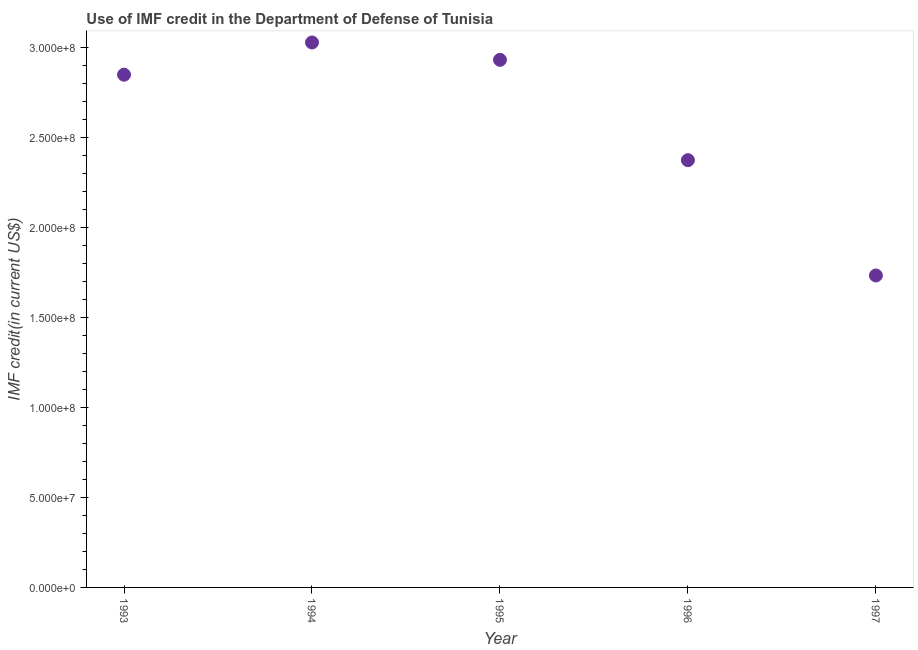What is the use of imf credit in dod in 1997?
Make the answer very short. 1.73e+08. Across all years, what is the maximum use of imf credit in dod?
Make the answer very short. 3.03e+08. Across all years, what is the minimum use of imf credit in dod?
Provide a succinct answer. 1.73e+08. In which year was the use of imf credit in dod minimum?
Ensure brevity in your answer.  1997. What is the sum of the use of imf credit in dod?
Offer a very short reply. 1.29e+09. What is the difference between the use of imf credit in dod in 1994 and 1995?
Give a very brief answer. 9.63e+06. What is the average use of imf credit in dod per year?
Provide a succinct answer. 2.58e+08. What is the median use of imf credit in dod?
Provide a succinct answer. 2.85e+08. Do a majority of the years between 1993 and 1995 (inclusive) have use of imf credit in dod greater than 190000000 US$?
Offer a terse response. Yes. What is the ratio of the use of imf credit in dod in 1993 to that in 1995?
Ensure brevity in your answer.  0.97. Is the use of imf credit in dod in 1993 less than that in 1997?
Keep it short and to the point. No. Is the difference between the use of imf credit in dod in 1994 and 1997 greater than the difference between any two years?
Your answer should be very brief. Yes. What is the difference between the highest and the second highest use of imf credit in dod?
Give a very brief answer. 9.63e+06. What is the difference between the highest and the lowest use of imf credit in dod?
Provide a succinct answer. 1.29e+08. In how many years, is the use of imf credit in dod greater than the average use of imf credit in dod taken over all years?
Your response must be concise. 3. Does the use of imf credit in dod monotonically increase over the years?
Offer a very short reply. No. Are the values on the major ticks of Y-axis written in scientific E-notation?
Your answer should be very brief. Yes. Does the graph contain grids?
Your answer should be very brief. No. What is the title of the graph?
Your answer should be compact. Use of IMF credit in the Department of Defense of Tunisia. What is the label or title of the Y-axis?
Provide a succinct answer. IMF credit(in current US$). What is the IMF credit(in current US$) in 1993?
Your response must be concise. 2.85e+08. What is the IMF credit(in current US$) in 1994?
Make the answer very short. 3.03e+08. What is the IMF credit(in current US$) in 1995?
Your answer should be compact. 2.93e+08. What is the IMF credit(in current US$) in 1996?
Offer a terse response. 2.37e+08. What is the IMF credit(in current US$) in 1997?
Your response must be concise. 1.73e+08. What is the difference between the IMF credit(in current US$) in 1993 and 1994?
Offer a terse response. -1.79e+07. What is the difference between the IMF credit(in current US$) in 1993 and 1995?
Keep it short and to the point. -8.26e+06. What is the difference between the IMF credit(in current US$) in 1993 and 1996?
Your response must be concise. 4.75e+07. What is the difference between the IMF credit(in current US$) in 1993 and 1997?
Offer a terse response. 1.12e+08. What is the difference between the IMF credit(in current US$) in 1994 and 1995?
Your answer should be very brief. 9.63e+06. What is the difference between the IMF credit(in current US$) in 1994 and 1996?
Ensure brevity in your answer.  6.54e+07. What is the difference between the IMF credit(in current US$) in 1994 and 1997?
Provide a succinct answer. 1.29e+08. What is the difference between the IMF credit(in current US$) in 1995 and 1996?
Your answer should be compact. 5.57e+07. What is the difference between the IMF credit(in current US$) in 1995 and 1997?
Offer a very short reply. 1.20e+08. What is the difference between the IMF credit(in current US$) in 1996 and 1997?
Provide a succinct answer. 6.40e+07. What is the ratio of the IMF credit(in current US$) in 1993 to that in 1994?
Give a very brief answer. 0.94. What is the ratio of the IMF credit(in current US$) in 1993 to that in 1995?
Provide a short and direct response. 0.97. What is the ratio of the IMF credit(in current US$) in 1993 to that in 1996?
Give a very brief answer. 1.2. What is the ratio of the IMF credit(in current US$) in 1993 to that in 1997?
Offer a very short reply. 1.64. What is the ratio of the IMF credit(in current US$) in 1994 to that in 1995?
Offer a very short reply. 1.03. What is the ratio of the IMF credit(in current US$) in 1994 to that in 1996?
Provide a succinct answer. 1.27. What is the ratio of the IMF credit(in current US$) in 1994 to that in 1997?
Offer a terse response. 1.75. What is the ratio of the IMF credit(in current US$) in 1995 to that in 1996?
Provide a succinct answer. 1.24. What is the ratio of the IMF credit(in current US$) in 1995 to that in 1997?
Keep it short and to the point. 1.69. What is the ratio of the IMF credit(in current US$) in 1996 to that in 1997?
Provide a short and direct response. 1.37. 